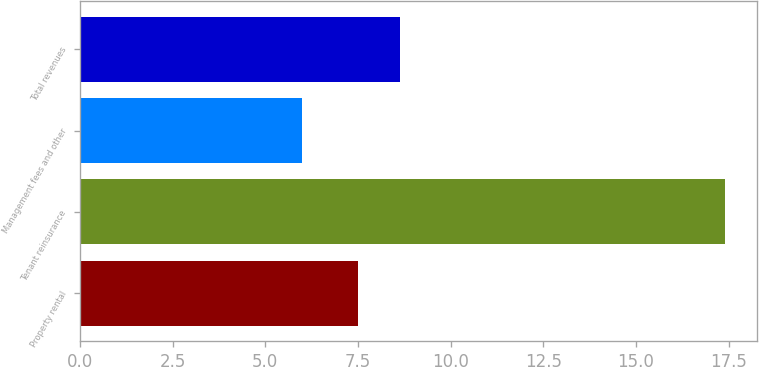<chart> <loc_0><loc_0><loc_500><loc_500><bar_chart><fcel>Property rental<fcel>Tenant reinsurance<fcel>Management fees and other<fcel>Total revenues<nl><fcel>7.5<fcel>17.4<fcel>6<fcel>8.64<nl></chart> 